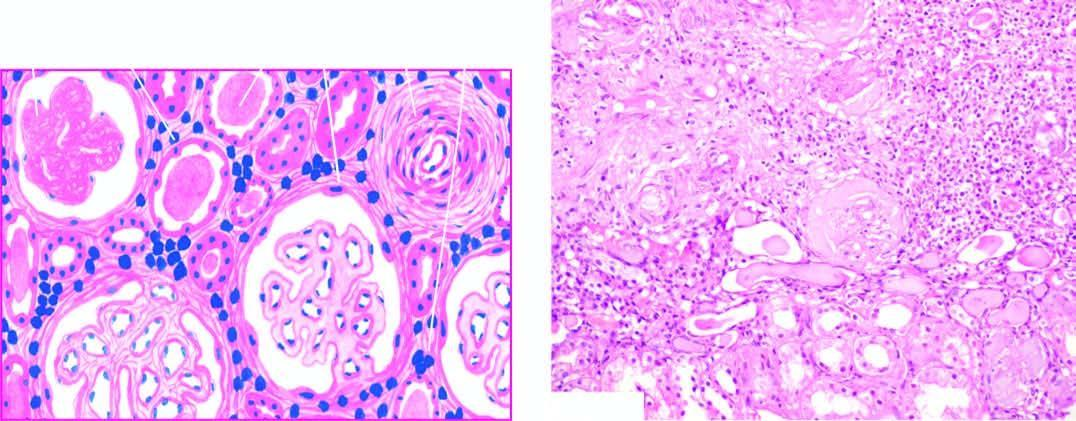what do the glomeruli show?
Answer the question using a single word or phrase. Periglomerular fibrosis 